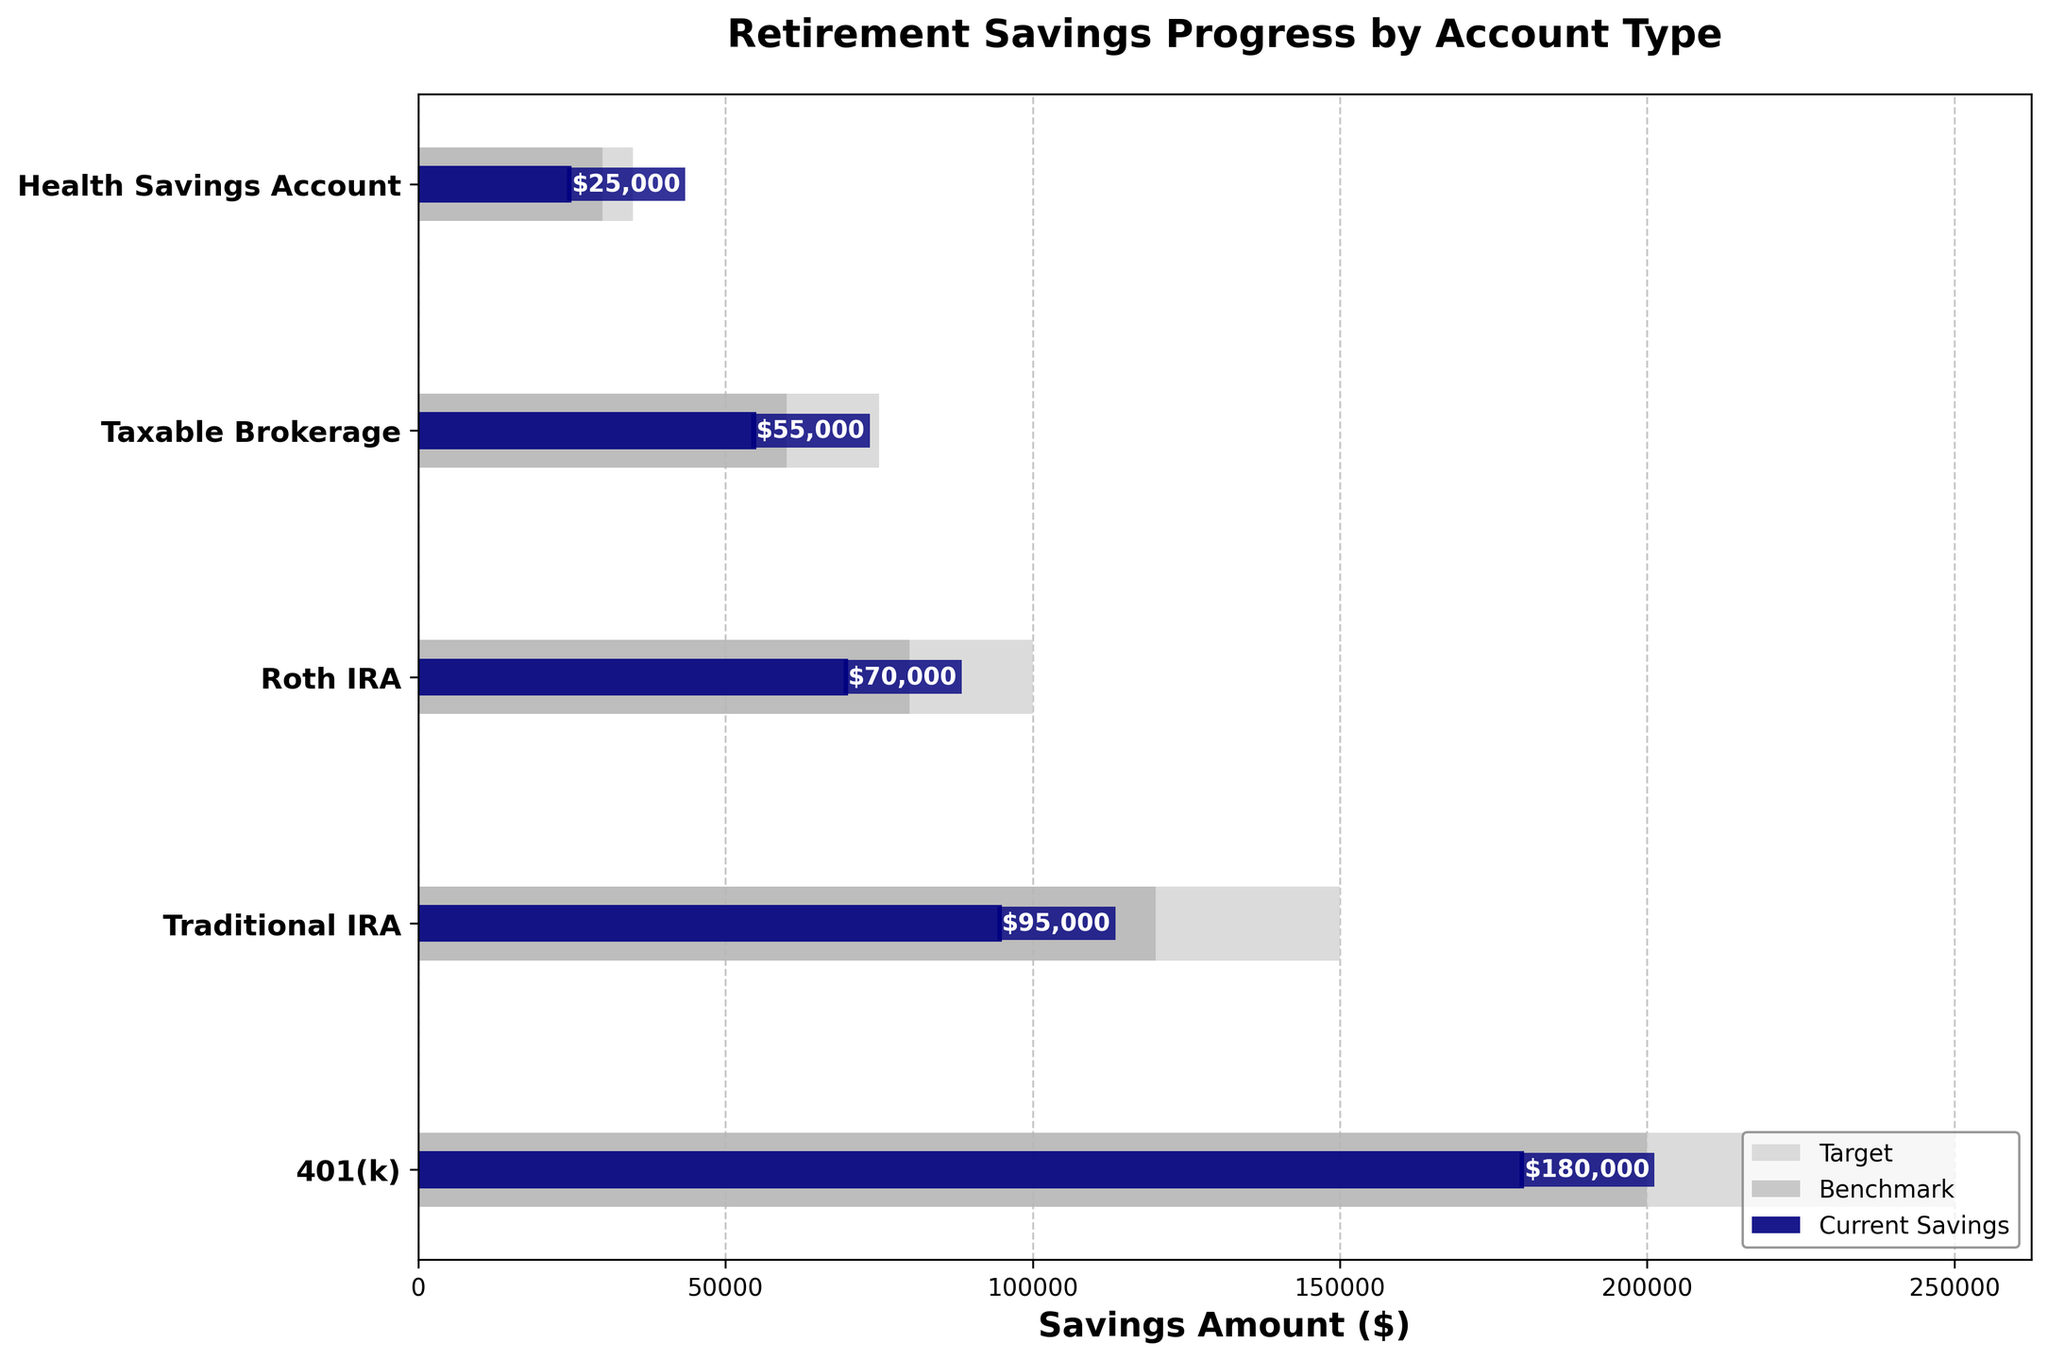what is the title of the figure? The title is displayed at the top of the figure, which summarizes the content.
Answer: Retirement Savings Progress by Account Type How many account types are represented in the figure? Count the number of different account types listed on the y-axis.
Answer: 5 Which account type has the highest current savings? Identify the bar with the highest length within the current savings category.
Answer: 401(k) What is the target savings amount for Roth IRA? Look for the target bar and identify the value at the end of the bar for Roth IRA.
Answer: $100,000 What is the difference between the current savings and benchmark for Taxable Brokerage? Subtract the benchmark value from the current savings value for Taxable Brokerage.
Answer: $5,000 How much more is needed to reach the target for the Health Savings Account? Subtract the current savings amount from the target savings amount for the Health Savings Account.
Answer: $10,000 Which account type is closest to its benchmark in terms of current savings? Compare the difference between current savings and the benchmark for each account type, and find the smallest difference.
Answer: Roth IRA By how much does the current savings for 401(k) exceed its benchmark? Subtract the benchmark value from the current savings value for 401(k).
Answer: $40,000 Which account type has the greatest shortfall from its target? For each account type, subtract the current savings from the target savings, and identify the account type with the largest result.
Answer: 401(k) What is the combined target savings amount across all account types? Add up the target savings amounts for all account types.
Answer: $610,000 